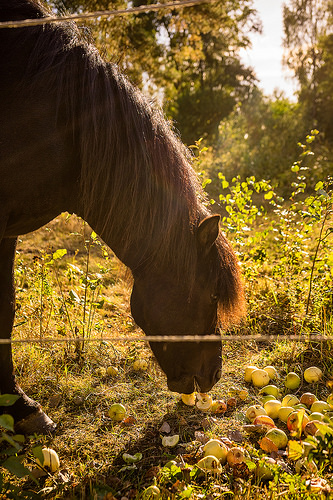<image>
Is the fence wire in front of the horse? Yes. The fence wire is positioned in front of the horse, appearing closer to the camera viewpoint. 